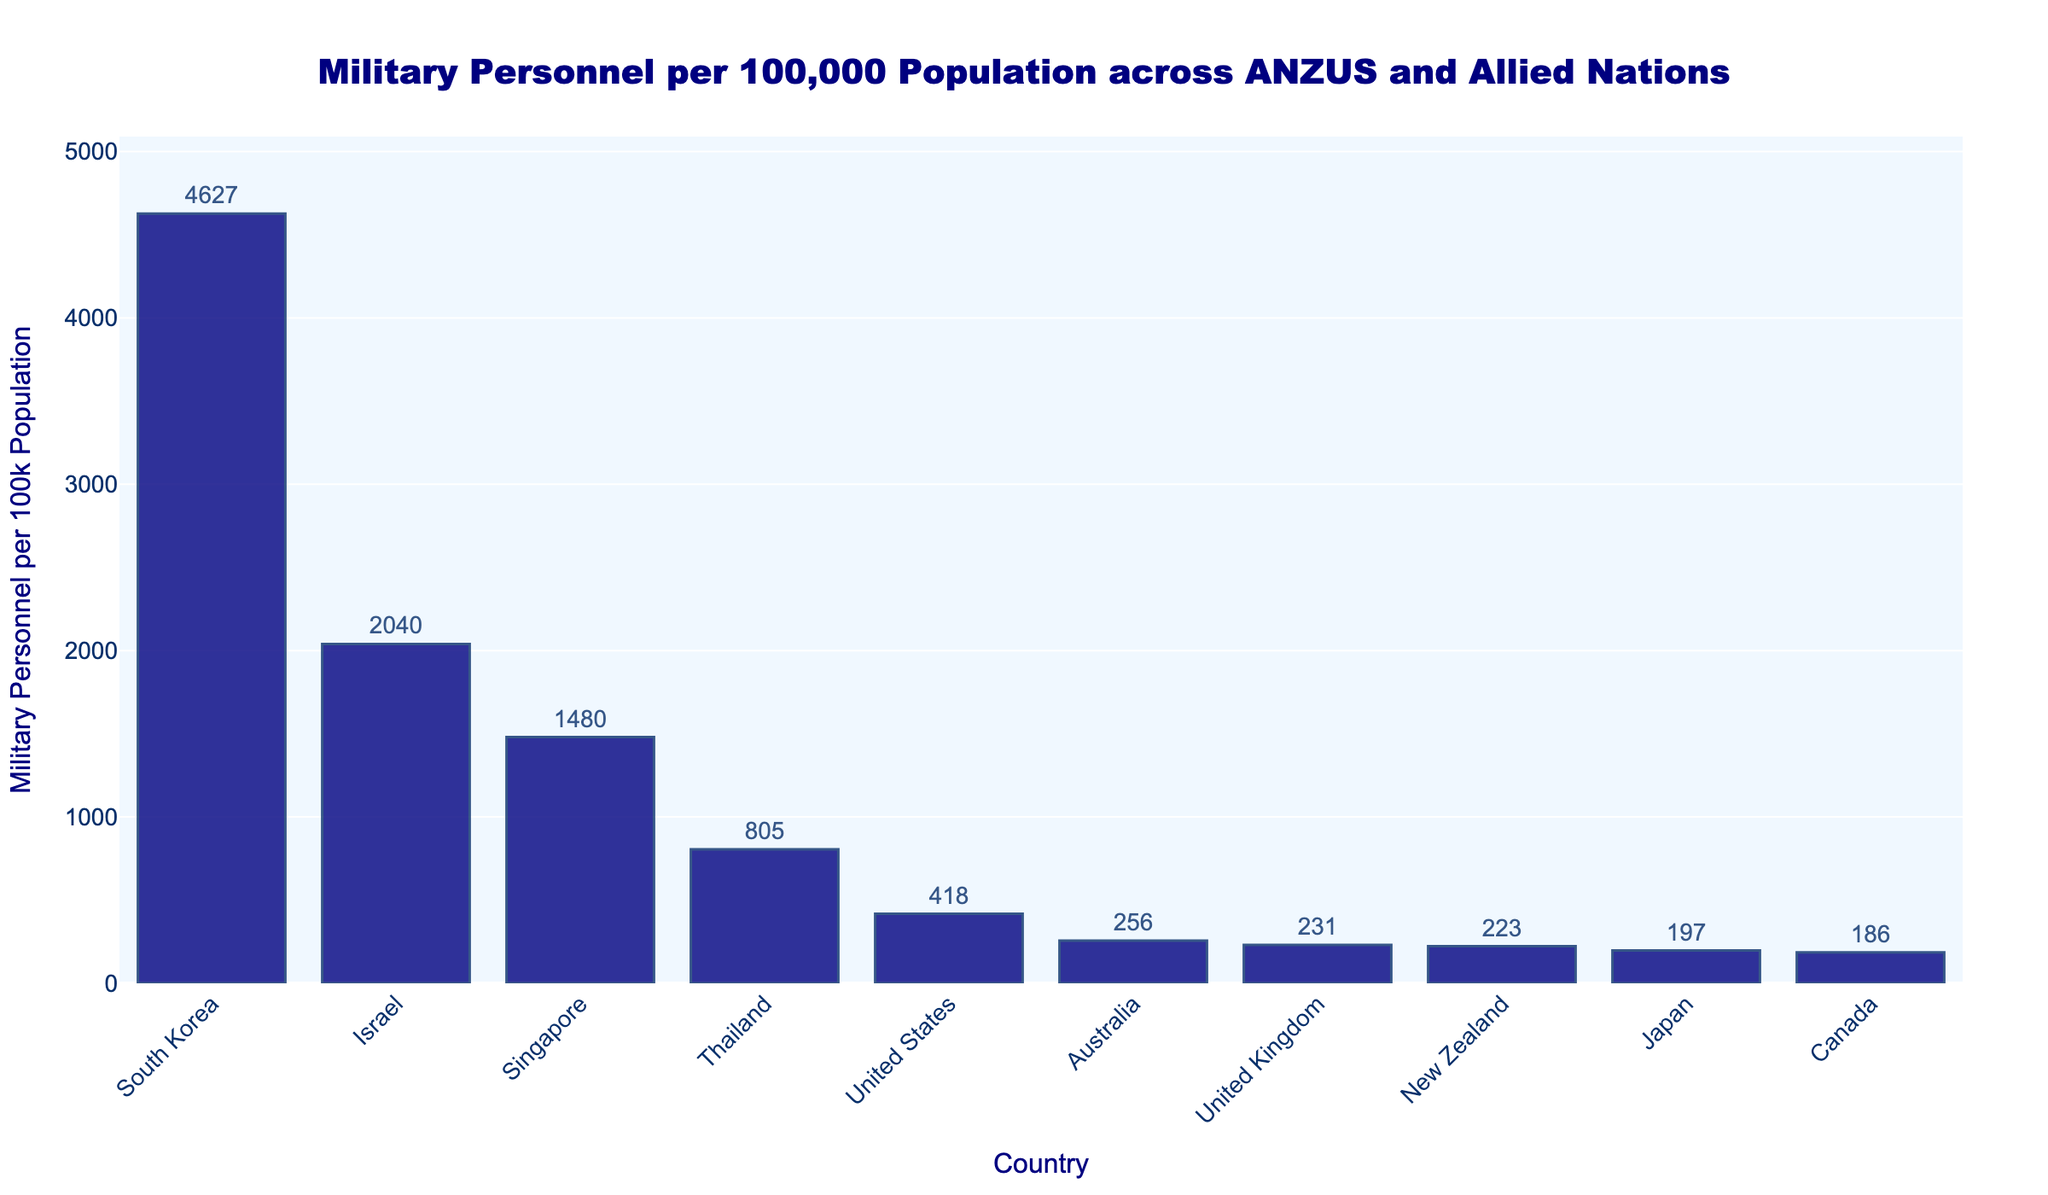Which country has the highest number of military personnel per 100,000 population? By looking at the figure, we can identify the tallest bar, which represents South Korea. It is the country with the highest number of military personnel per 100,000 population.
Answer: South Korea How does New Zealand's military personnel per capita compare to Australia's? Locate the bars for New Zealand and Australia on the chart. New Zealand has 223 military personnel per 100k population, while Australia has 256. Australia's is higher.
Answer: Australia has more What is the total number of military personnel per 100k population for New Zealand, Australia, and the United States combined? Add the values for these three countries: New Zealand (223), Australia (256), and the United States (418). The sum is 223 + 256 + 418.
Answer: 897 Which countries have fewer military personnel per 100,000 population than Canada? Locate the bar for Canada, with 186 military personnel per 100k population. Then, identify the countries with bars that are shorter than Canada's: Japan and Singapore.
Answer: Japan, Singapore What is the difference in military personnel per capita between the country with the highest and lowest values? Identify the highest value (South Korea with 4627) and the lowest value (Israel with 197). Calculate the difference: 4627 - 197.
Answer: 4430 Is the military personnel per capita for Thailand more than twice that of the United Kingdom? Compare the heights of the bars for Thailand (805) and United Kingdom (231). Twice the United Kingdom’s value is 231 * 2 = 462. Since 805 is greater than 462, the answer is yes.
Answer: Yes How do the military personnel per capita for Japan and the United Kingdom compare? By comparing the height of the bars, Japan has 197 military personnel per 100k population, while the United Kingdom has 231. The United Kingdom has more.
Answer: United Kingdom has more Which country has the closest number of military personnel per 100k population to New Zealand? Identify New Zealand's value (223) and look for the country with the closest value: the United Kingdom with 231 is the closest.
Answer: United Kingdom What is the mean number of military personnel per 100k population for the United States, Israel, and South Korea? Calculate the mean by summing their values and dividing by the number of countries. (418 + 2040 + 4627) / 3 = 7085 / 3.
Answer: 2361.67 Which country has a bar colored differently and why might that be significant? The question is a trick; all bars are colored navy. This consistency suggests no particular emphasis or differentiation in the color scheme itself.
Answer: All bars are navy 